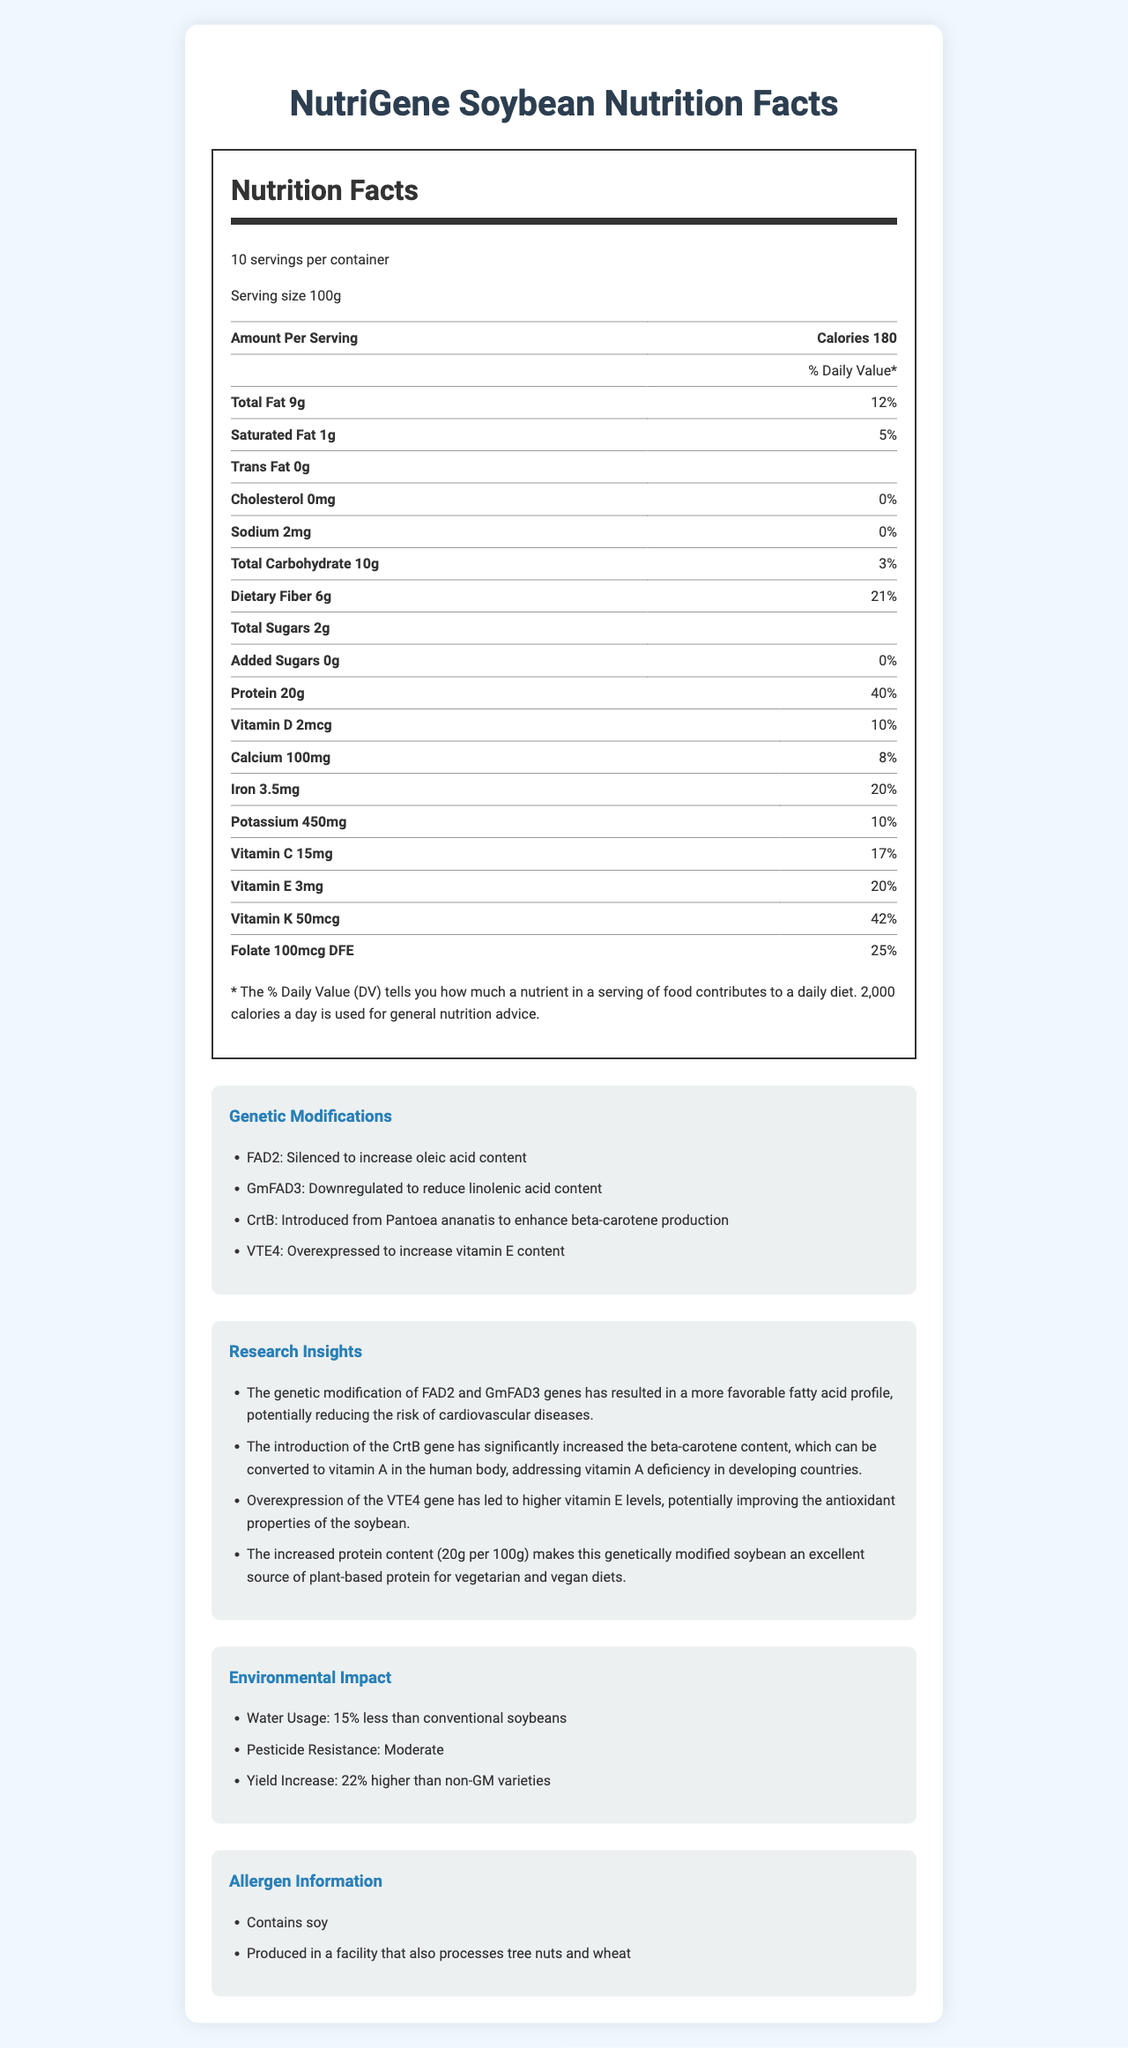what is the total fat per serving? The total fat per serving is provided in the macronutrients section under the "Total Fat" category.
Answer: 9g what percentage of the daily value is the dietary fiber? The daily value percentage for dietary fiber is mentioned in the macronutrients section under "Dietary Fiber."
Answer: 21% which gene was introduced to enhance beta-carotene production? The CrtB gene was introduced to enhance beta-carotene production as mentioned under the "Genetic Modifications" section.
Answer: CrtB what is the protein content per serving? The protein content per serving is specified in the macronutrients section under the "Protein" category.
Answer: 20g does this product contain any trans fat? The document states "Trans Fat 0g" in the macronutrients section, meaning it contains no trans fat.
Answer: No what are the vitamins present in this product? A. Vitamin C, Vitamin D, and Vitamin K B. Vitamin A, Vitamin D, and Vitamin E C. Vitamin C, Vitamin A, and Vitamin K D. Vitamin D, Vitamin E, and Vitamin K The vitamins present are found in the "vitamins and minerals" section and include Vitamin C, Vitamin D, and Vitamin K.
Answer: A which genetic modification is associated with reducing the risk of cardiovascular diseases? A. Silencing of FAD2 gene B. Downregulation of GmFAD3 gene C. Overexpression of VTE4 gene D. Introduction of CrtB gene The research insights state that silencing the FAD2 and downregulating GmFAD3 genes lead to a more favorable fatty acid profile, potentially reducing cardiovascular disease risk.
Answer: A is the soybean safe for those with nut allergies? The allergen information states that the product is produced in a facility that also processes tree nuts, which may pose a risk for those with nut allergies.
Answer: No what is the overall summary of the document? The document offers a comprehensive view of "NutriGene Soybean," focusing on nutritional details, genetic enhancements, benefits from research, environmental advantages, and allergy considerations.
Answer: The document provides detailed nutritional information about the "NutriGene Soybean," including its macronutrient profile, genetic modifications, research insights, environmental impacts, and allergen information. It highlights the enhanced nutritional value due to genetic modifications that increase beneficial nutrients and decrease harmful components. The document also outlines the environmental benefits and allergen warnings. how much more yield does the genetically modified soybean produce compared to non-GM varieties? The environmental impact section states that the yield of the genetically modified soybean is 22% higher than non-GM varieties.
Answer: 22% higher does the document provide information on the specific improvement in vitamin A levels? The document explains that the introduction of the CrtB gene enhances beta-carotene, a precursor to vitamin A, but it does not provide specific quantitative data on the improvement in vitamin A levels.
Answer: Not enough information 